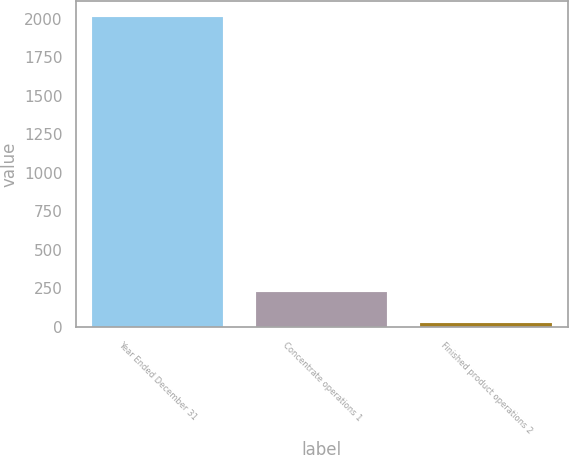Convert chart. <chart><loc_0><loc_0><loc_500><loc_500><bar_chart><fcel>Year Ended December 31<fcel>Concentrate operations 1<fcel>Finished product operations 2<nl><fcel>2013<fcel>226.5<fcel>28<nl></chart> 